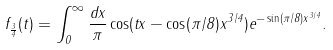Convert formula to latex. <formula><loc_0><loc_0><loc_500><loc_500>f _ { \frac { 3 } { 4 } } ( t ) = \int _ { 0 } ^ { \infty } \frac { d x } { \pi } \cos ( t x - \cos ( \pi / 8 ) x ^ { 3 / 4 } ) e ^ { - \sin ( \pi / 8 ) x ^ { 3 / 4 } } .</formula> 